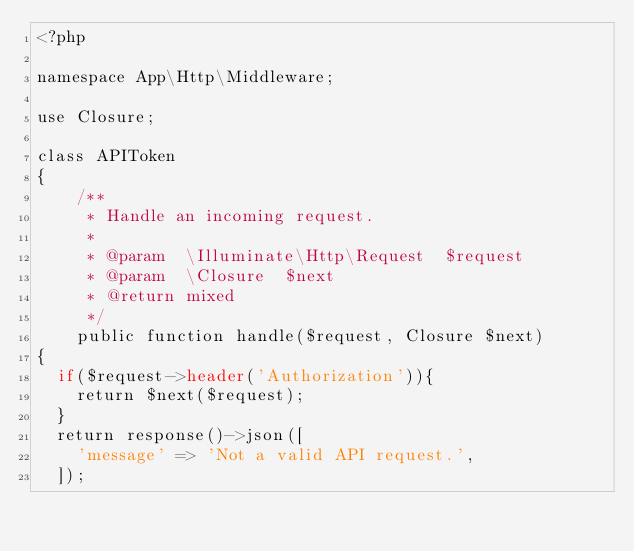Convert code to text. <code><loc_0><loc_0><loc_500><loc_500><_PHP_><?php

namespace App\Http\Middleware;

use Closure;

class APIToken
{
    /**
     * Handle an incoming request.
     *
     * @param  \Illuminate\Http\Request  $request
     * @param  \Closure  $next
     * @return mixed
     */
    public function handle($request, Closure $next)
{
  if($request->header('Authorization')){
    return $next($request);
  }
  return response()->json([
    'message' => 'Not a valid API request.',
  ]);

</code> 